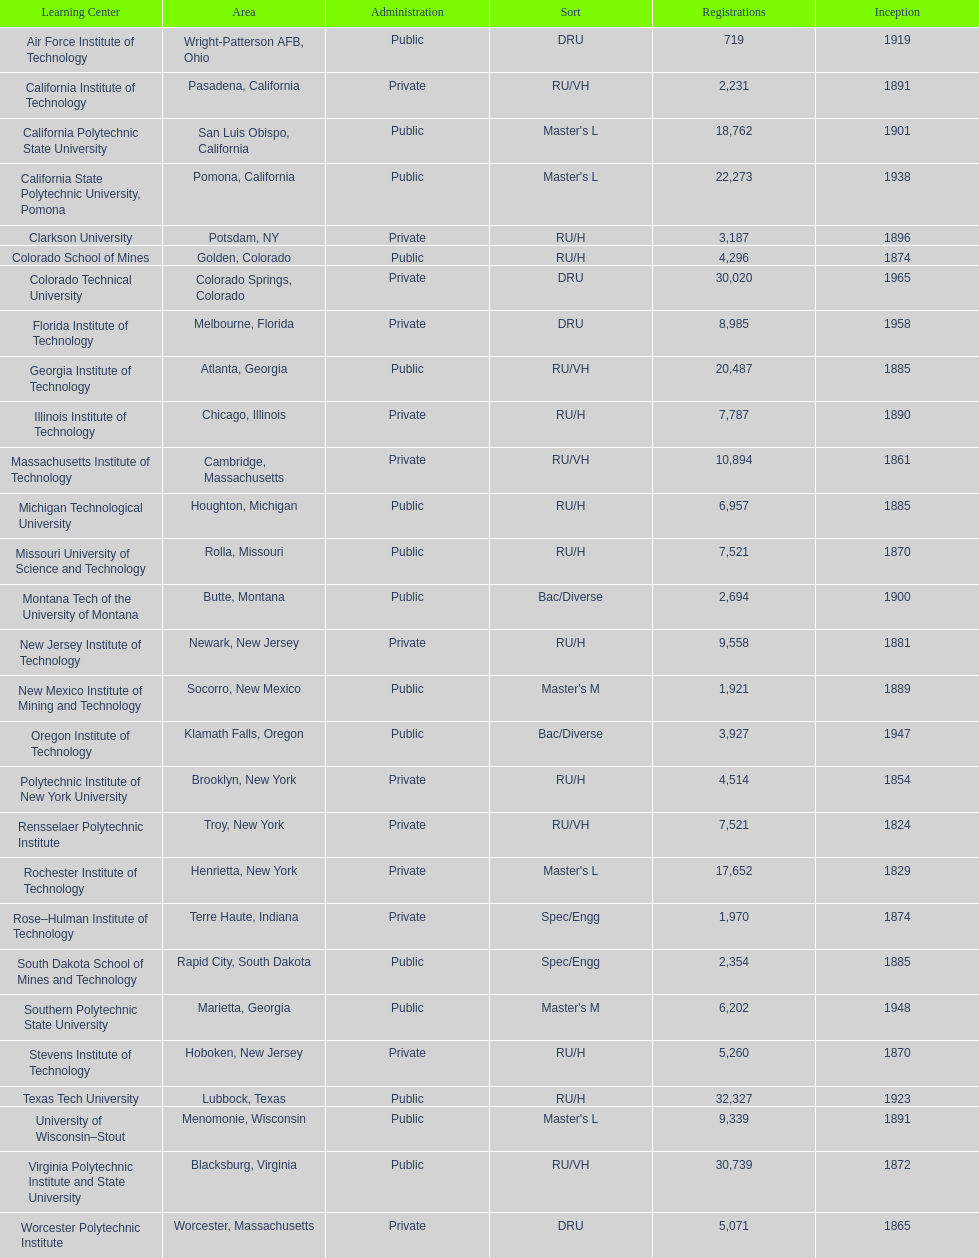What school is listed next after michigan technological university? Missouri University of Science and Technology. 